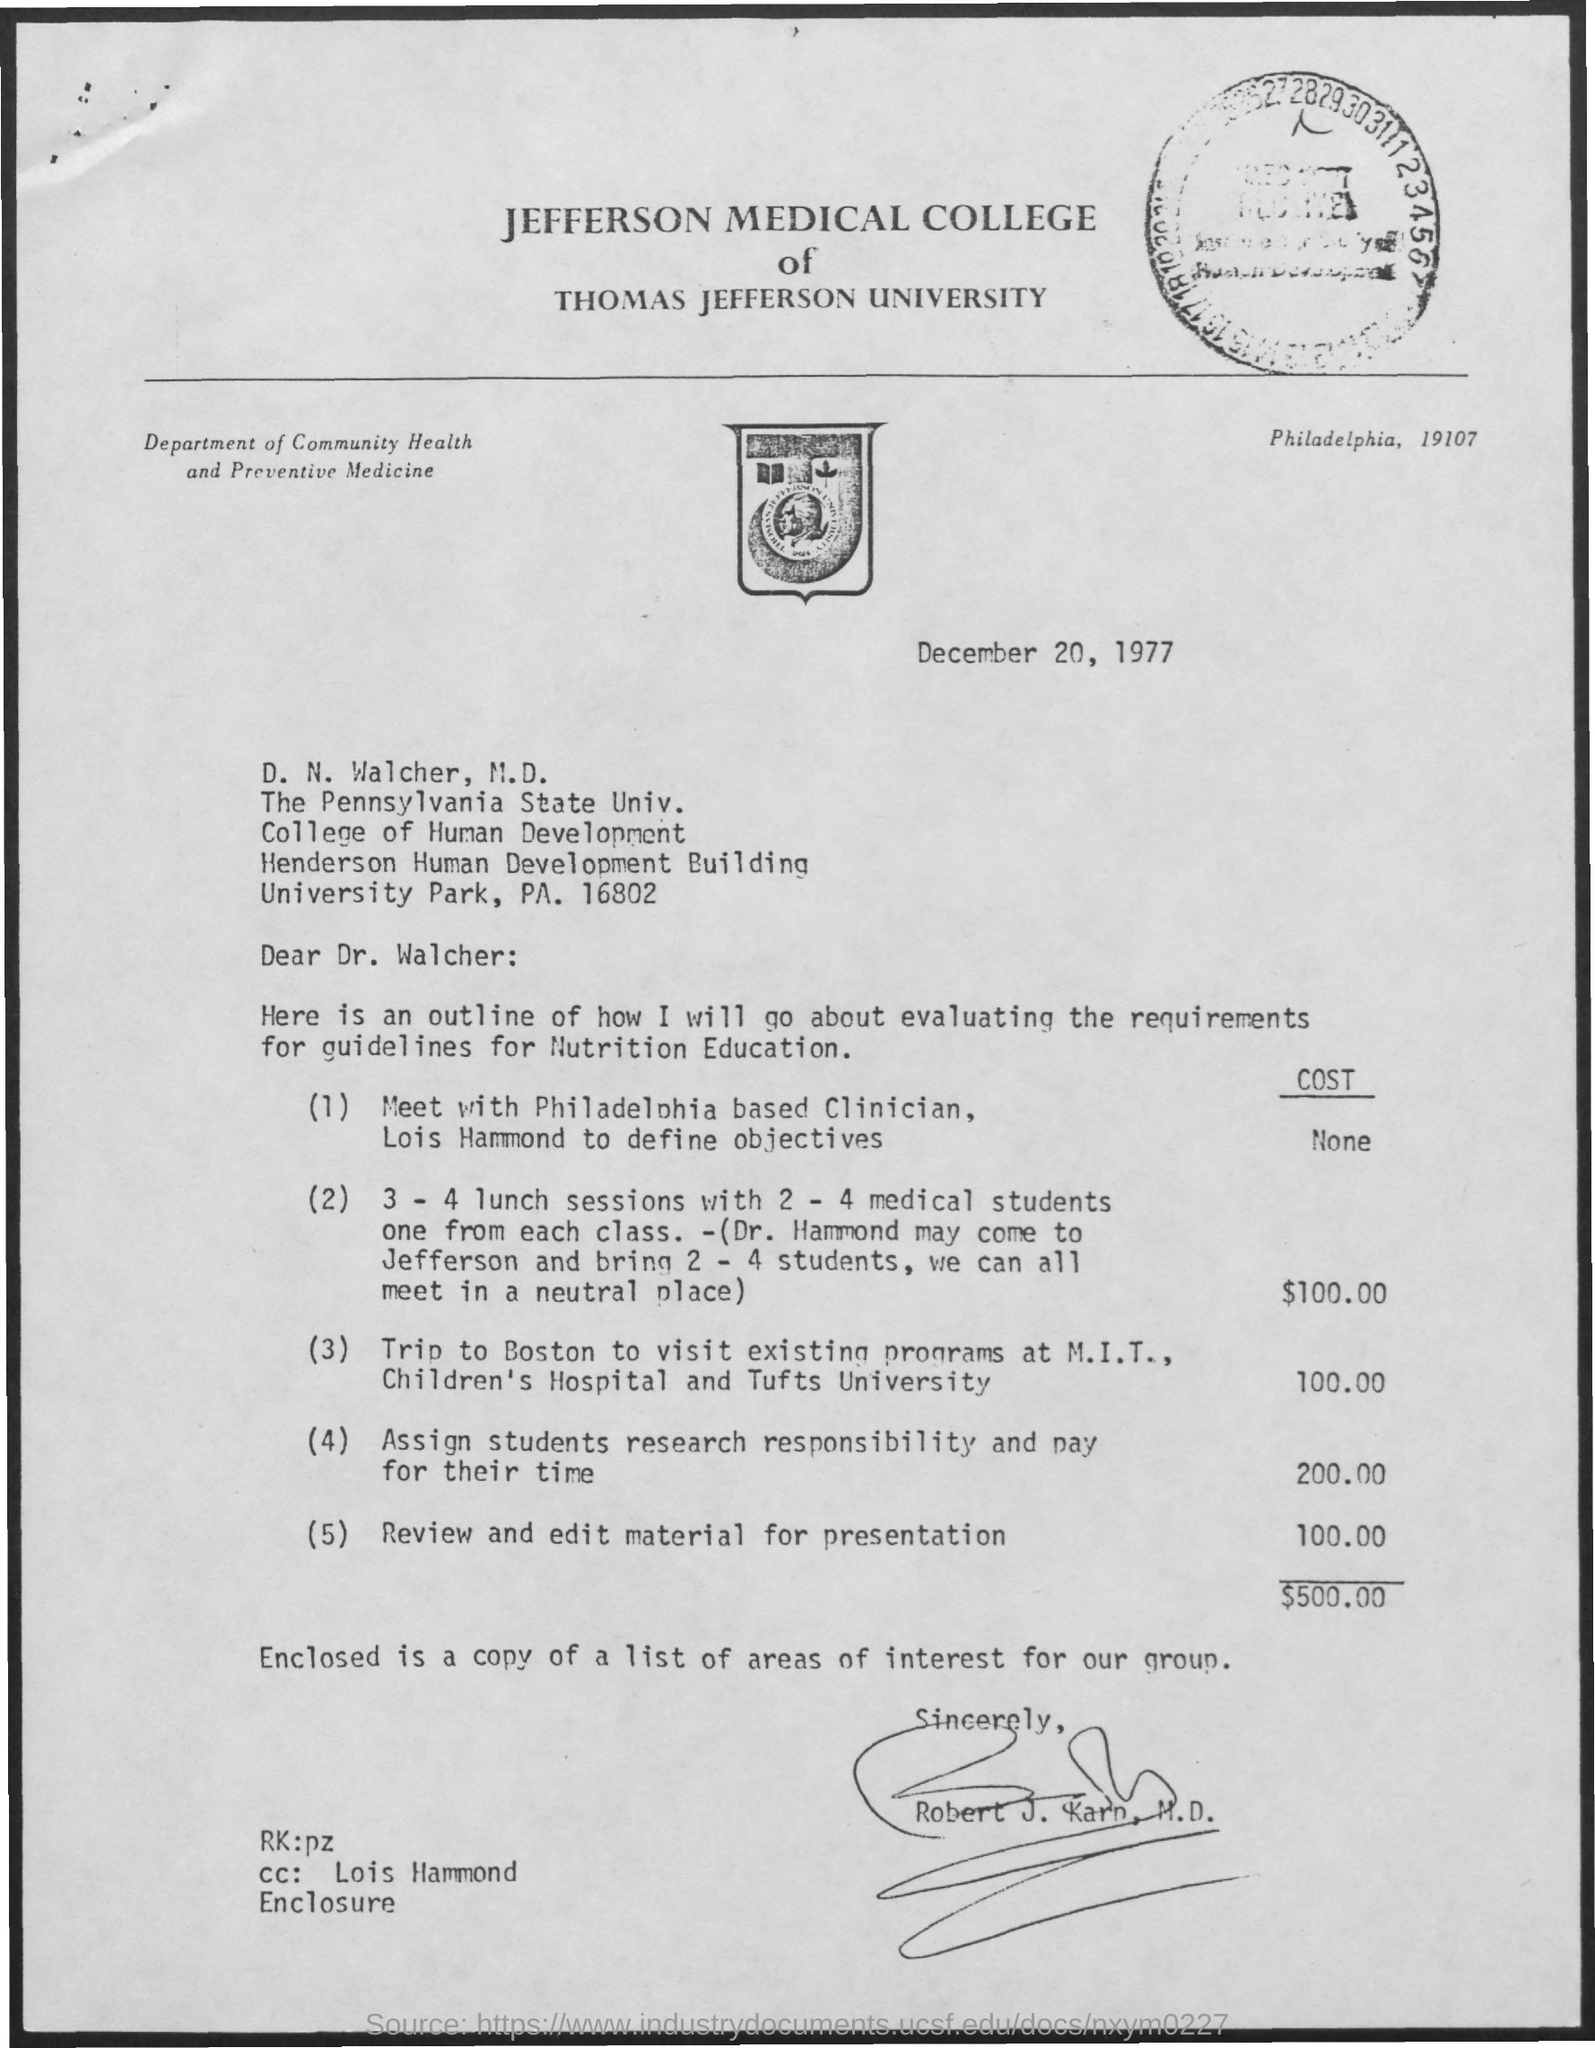Letter head of which MEDICAL COLLEGE is seen here?
Keep it short and to the point. JEFFERSON MEDICAL COLLEGE. JEFFERSON MEDICAL COLLEGE comes under which "UNIVERSITY"?
Offer a very short reply. Thomas Jefferson university. When is this letter written?
Ensure brevity in your answer.  December 20, 1997. To whom is this letter addressed to?
Ensure brevity in your answer.  D. N.  Walcher, M.D. Who has drafted this letter?
Your answer should be compact. Robert J.  Karp, M.D. Which "Department" name is written on the top left side of letter?
Ensure brevity in your answer.  Community Health and Preventive Medicine. D. N.  Walcher is from which "college"?
Ensure brevity in your answer.  College of Human Development. What is the cost  required for "Review and edit material for presentation"?
Give a very brief answer. 100. "cc:" of the letter is sent to whom?
Keep it short and to the point. Lois Hammond. What is the total "cost" required ?
Keep it short and to the point. $500. 